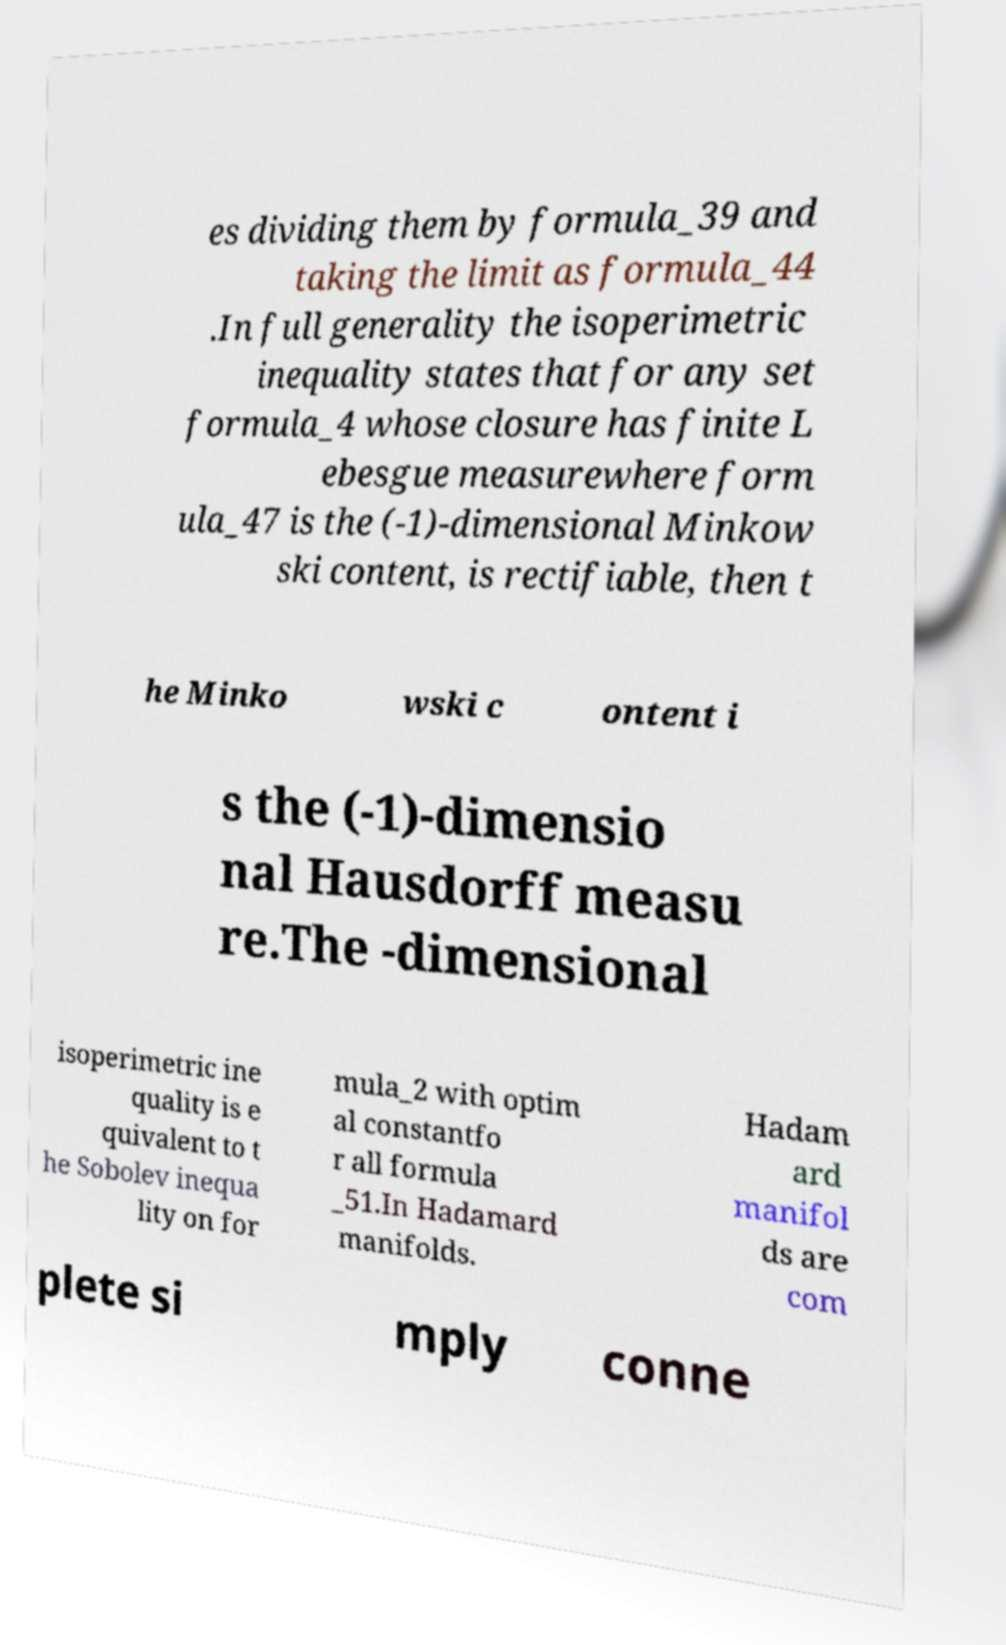Please identify and transcribe the text found in this image. es dividing them by formula_39 and taking the limit as formula_44 .In full generality the isoperimetric inequality states that for any set formula_4 whose closure has finite L ebesgue measurewhere form ula_47 is the (-1)-dimensional Minkow ski content, is rectifiable, then t he Minko wski c ontent i s the (-1)-dimensio nal Hausdorff measu re.The -dimensional isoperimetric ine quality is e quivalent to t he Sobolev inequa lity on for mula_2 with optim al constantfo r all formula _51.In Hadamard manifolds. Hadam ard manifol ds are com plete si mply conne 